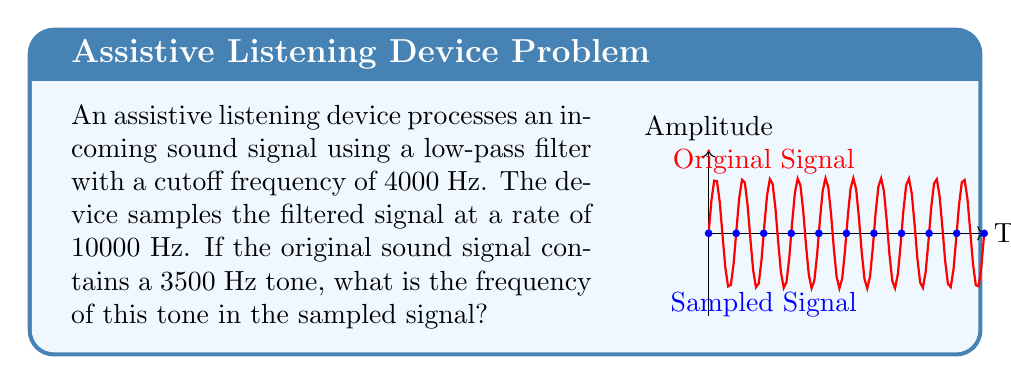Show me your answer to this math problem. Let's approach this step-by-step:

1) The Nyquist-Shannon sampling theorem states that to accurately reconstruct a signal, the sampling rate must be at least twice the highest frequency component of the signal.

2) In this case, the sampling rate is 10000 Hz, which means the maximum frequency that can be accurately represented is:

   $$f_{max} = \frac{10000}{2} = 5000 \text{ Hz}$$

3) The original signal contains a 3500 Hz tone, which is below this maximum frequency. Therefore, it will not be aliased.

4) When a signal is sampled, frequencies in the original signal appear unchanged in the sampled signal, as long as they are below the Nyquist frequency (half the sampling rate).

5) Since 3500 Hz is below the Nyquist frequency of 5000 Hz, the frequency of this tone in the sampled signal will be the same as in the original signal.

Therefore, the 3500 Hz tone in the original signal will appear as a 3500 Hz tone in the sampled signal.
Answer: 3500 Hz 